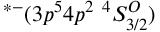Convert formula to latex. <formula><loc_0><loc_0><loc_500><loc_500>^ { * - } ( 3 p ^ { 5 } 4 p ^ { 2 } \ ^ { 4 } S _ { 3 / 2 } ^ { O } )</formula> 